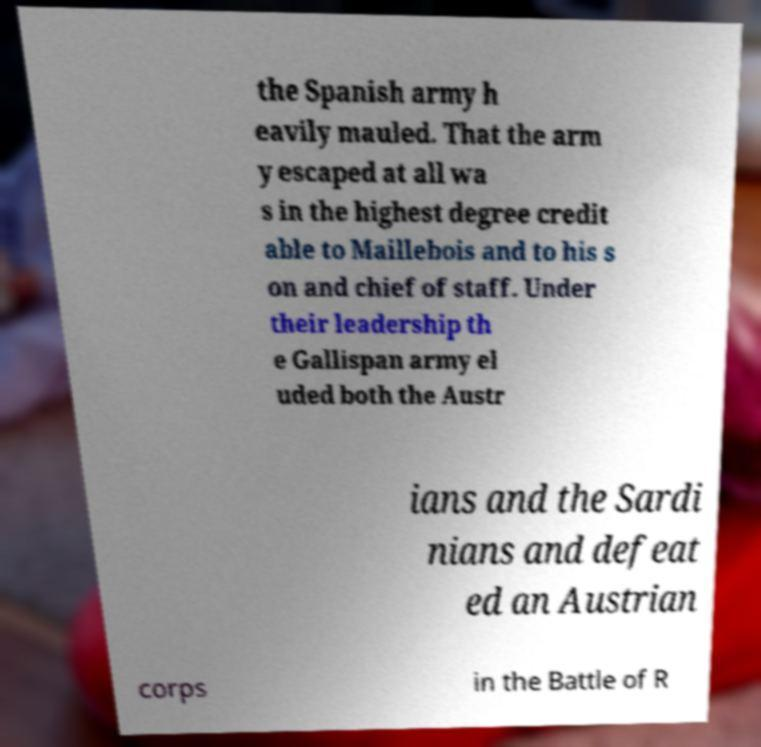Can you accurately transcribe the text from the provided image for me? the Spanish army h eavily mauled. That the arm y escaped at all wa s in the highest degree credit able to Maillebois and to his s on and chief of staff. Under their leadership th e Gallispan army el uded both the Austr ians and the Sardi nians and defeat ed an Austrian corps in the Battle of R 